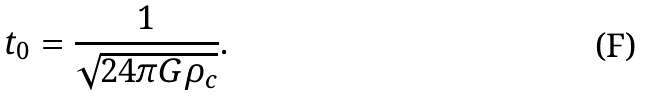Convert formula to latex. <formula><loc_0><loc_0><loc_500><loc_500>t _ { 0 } = \frac { 1 } { \sqrt { 2 4 \pi G \rho _ { c } } } .</formula> 